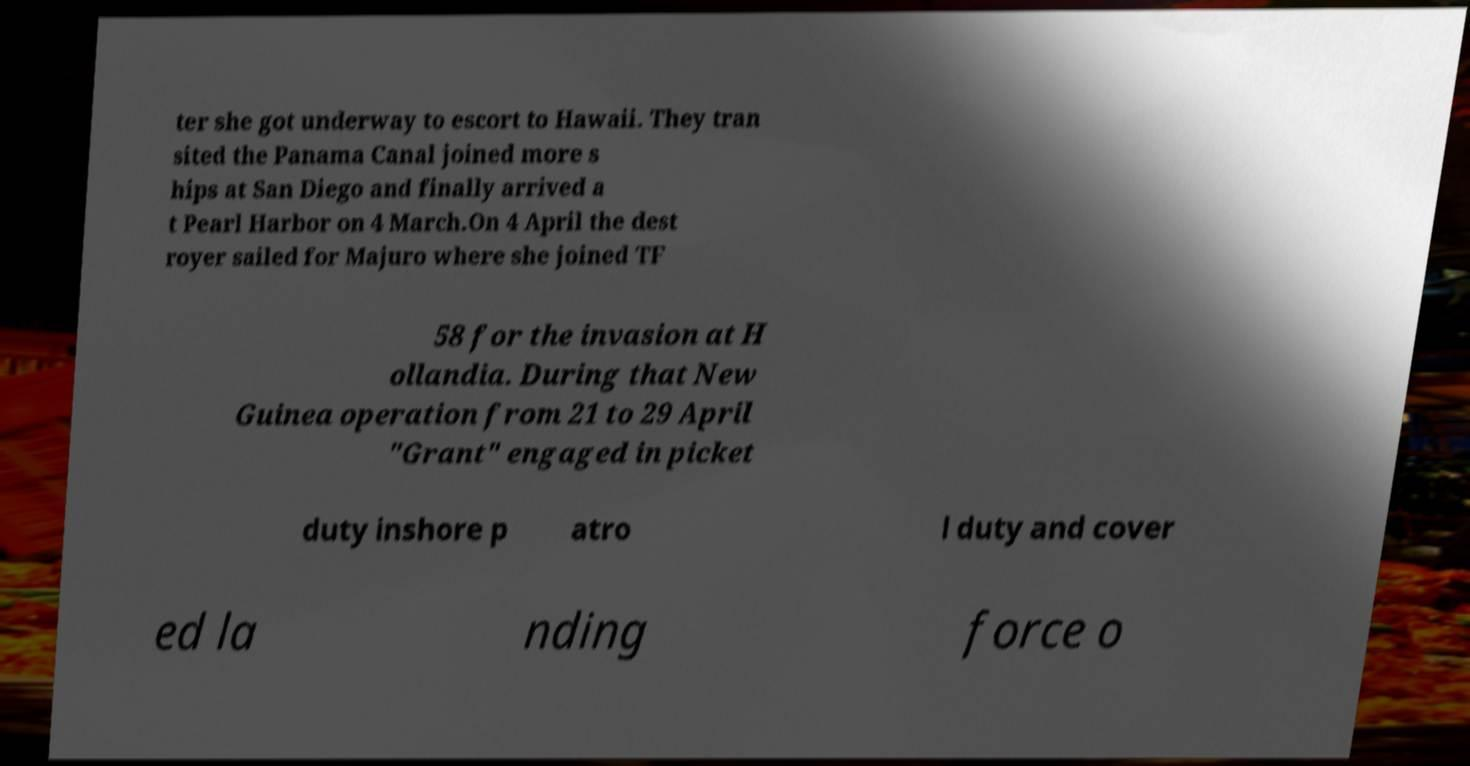Could you assist in decoding the text presented in this image and type it out clearly? ter she got underway to escort to Hawaii. They tran sited the Panama Canal joined more s hips at San Diego and finally arrived a t Pearl Harbor on 4 March.On 4 April the dest royer sailed for Majuro where she joined TF 58 for the invasion at H ollandia. During that New Guinea operation from 21 to 29 April "Grant" engaged in picket duty inshore p atro l duty and cover ed la nding force o 